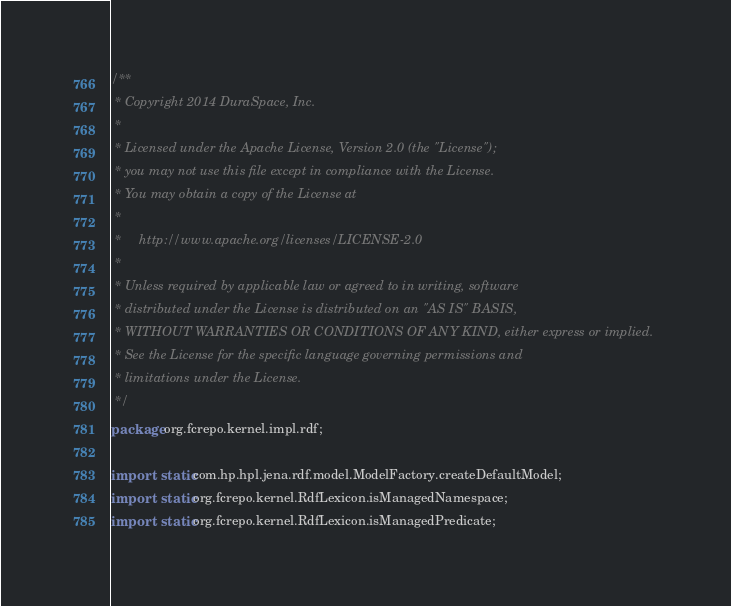<code> <loc_0><loc_0><loc_500><loc_500><_Java_>/**
 * Copyright 2014 DuraSpace, Inc.
 *
 * Licensed under the Apache License, Version 2.0 (the "License");
 * you may not use this file except in compliance with the License.
 * You may obtain a copy of the License at
 *
 *     http://www.apache.org/licenses/LICENSE-2.0
 *
 * Unless required by applicable law or agreed to in writing, software
 * distributed under the License is distributed on an "AS IS" BASIS,
 * WITHOUT WARRANTIES OR CONDITIONS OF ANY KIND, either express or implied.
 * See the License for the specific language governing permissions and
 * limitations under the License.
 */
package org.fcrepo.kernel.impl.rdf;

import static com.hp.hpl.jena.rdf.model.ModelFactory.createDefaultModel;
import static org.fcrepo.kernel.RdfLexicon.isManagedNamespace;
import static org.fcrepo.kernel.RdfLexicon.isManagedPredicate;
</code> 